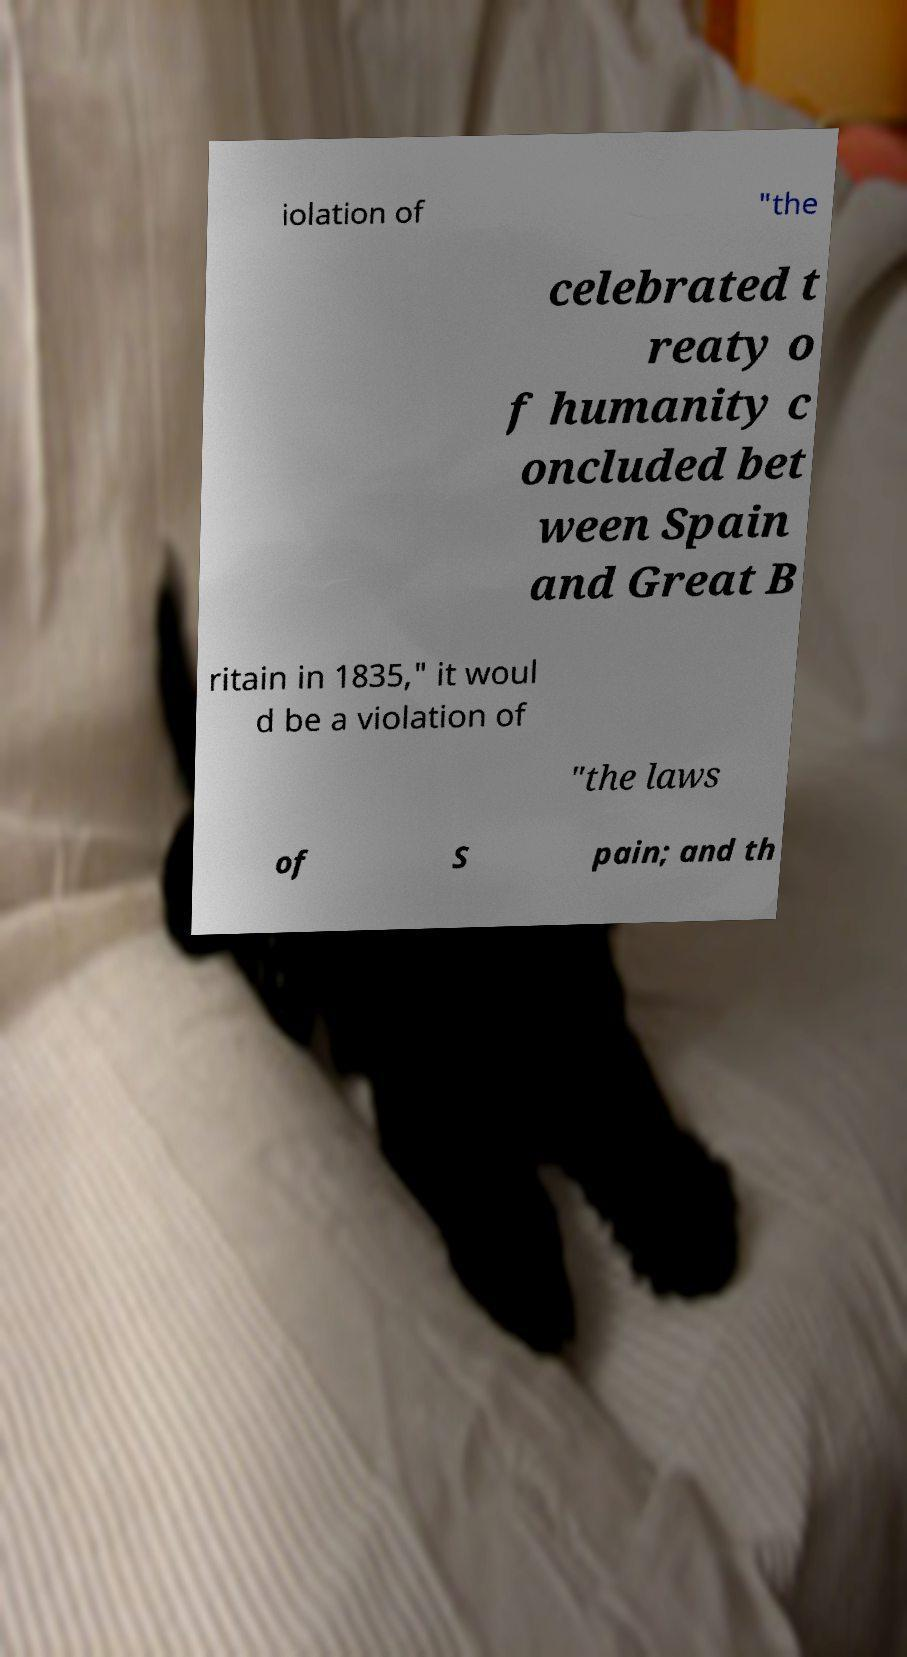Please read and relay the text visible in this image. What does it say? iolation of "the celebrated t reaty o f humanity c oncluded bet ween Spain and Great B ritain in 1835," it woul d be a violation of "the laws of S pain; and th 